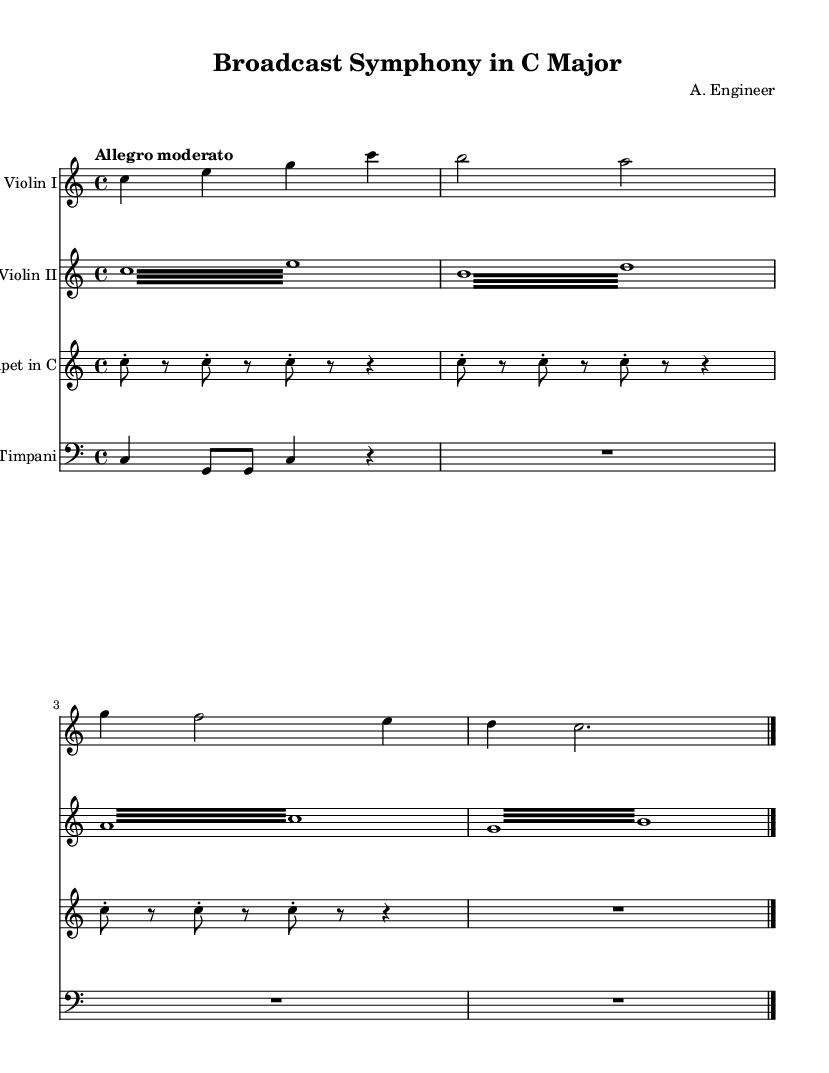What is the key signature of this music? The key signature is C major, which is indicated at the beginning of the score. There are no sharps or flats present, confirming the key of C major.
Answer: C major What is the time signature of the piece? The time signature is found at the start of the score, which shows 4/4. This means there are four beats in each measure and a quarter note receives one beat.
Answer: 4/4 What is the tempo marking given for this composition? The tempo marking is included at the beginning of the score, which specifies "Allegro moderato," indicating a moderately fast tempo.
Answer: Allegro moderato How many total measures are present in the violin I part? To find the total number of measures, we count the individual measures present in the sheet music for violin I, which includes one full measure at the end and multiple measures within the part. The total is four measures in the violin I part.
Answer: 4 What instruments are featured in this symphony? The instruments are listed at the beginning of each staff, including Violin I, Violin II, Trumpet in C, and Timpani. Each staff represents one of the instruments in the symphony.
Answer: Violin I, Violin II, Trumpet in C, Timpani Which instrument has a repeated motif in the score? The question asks for the instrument that shows a motif repeating in its part. The trumpet section uses a motif of repeated notes C with rests between them, demonstrating a rhythmic pattern.
Answer: Trumpet in C 